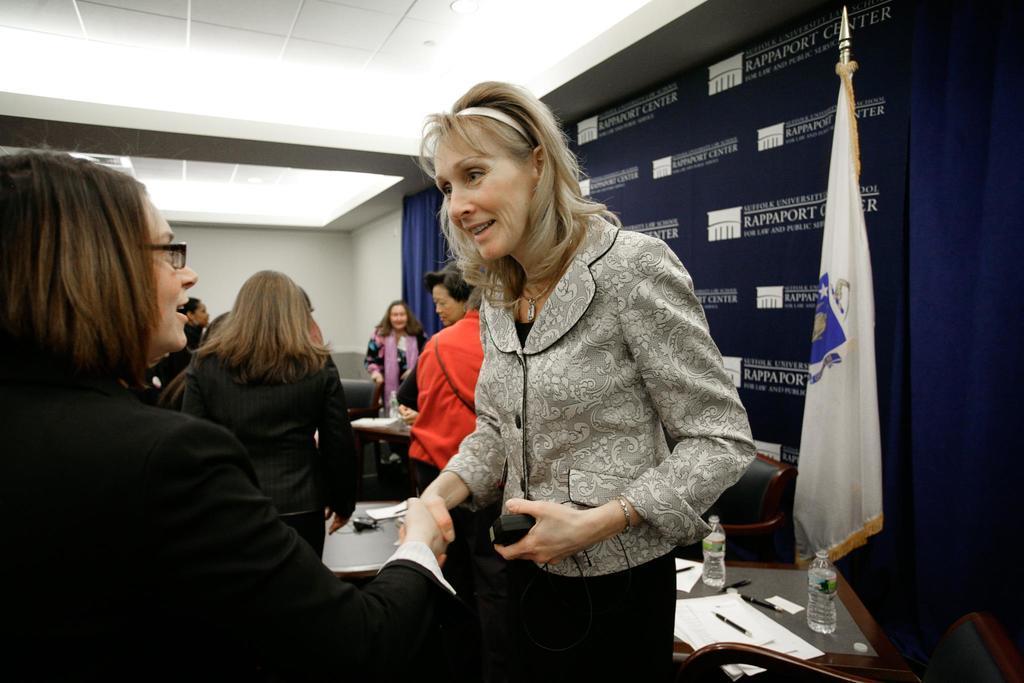How would you summarize this image in a sentence or two? In this picture I can see group of women among them the woman in the front are giving shake hands to each other. In the background I can see white color wall and ceiling. On the right side I can see flag, table on which I can see bottles, pen, papers and other objects on it. 